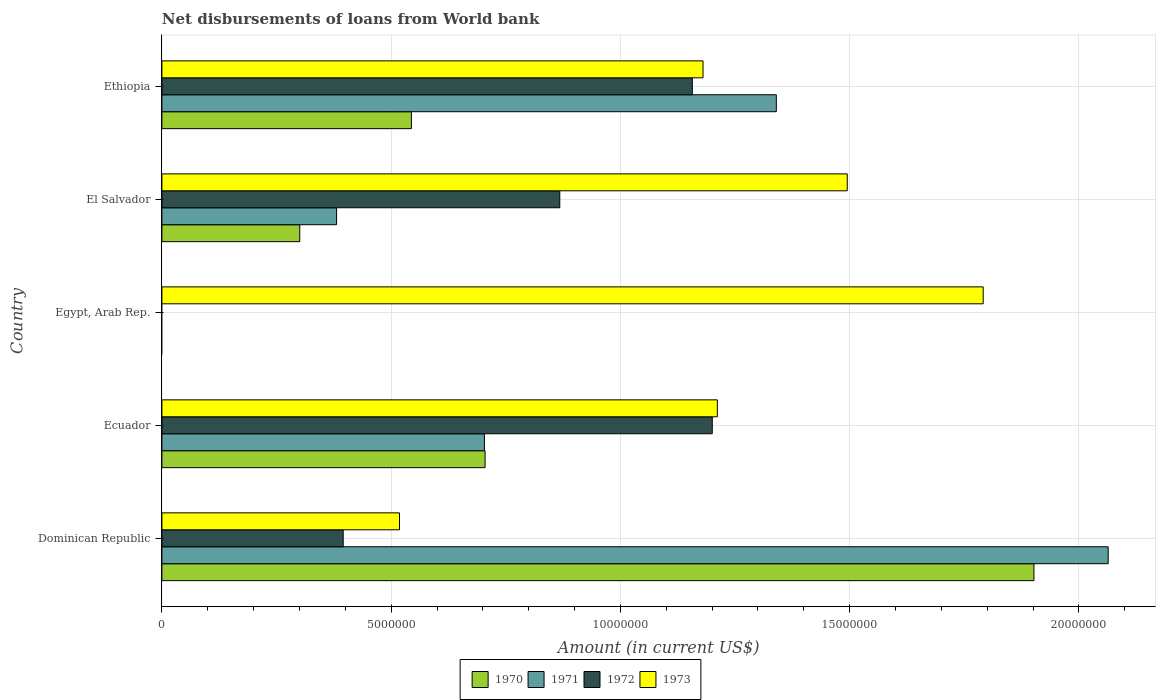How many different coloured bars are there?
Your answer should be compact. 4. How many bars are there on the 4th tick from the bottom?
Make the answer very short. 4. What is the label of the 5th group of bars from the top?
Offer a very short reply. Dominican Republic. In how many cases, is the number of bars for a given country not equal to the number of legend labels?
Give a very brief answer. 1. What is the amount of loan disbursed from World Bank in 1973 in Ethiopia?
Offer a very short reply. 1.18e+07. Across all countries, what is the maximum amount of loan disbursed from World Bank in 1972?
Offer a very short reply. 1.20e+07. In which country was the amount of loan disbursed from World Bank in 1972 maximum?
Keep it short and to the point. Ecuador. What is the total amount of loan disbursed from World Bank in 1973 in the graph?
Make the answer very short. 6.20e+07. What is the difference between the amount of loan disbursed from World Bank in 1973 in Dominican Republic and that in Ethiopia?
Your answer should be compact. -6.62e+06. What is the difference between the amount of loan disbursed from World Bank in 1971 in Egypt, Arab Rep. and the amount of loan disbursed from World Bank in 1973 in Ethiopia?
Your response must be concise. -1.18e+07. What is the average amount of loan disbursed from World Bank in 1970 per country?
Your answer should be compact. 6.90e+06. What is the difference between the amount of loan disbursed from World Bank in 1972 and amount of loan disbursed from World Bank in 1973 in Dominican Republic?
Your answer should be compact. -1.23e+06. In how many countries, is the amount of loan disbursed from World Bank in 1973 greater than 20000000 US$?
Give a very brief answer. 0. What is the ratio of the amount of loan disbursed from World Bank in 1973 in Dominican Republic to that in El Salvador?
Make the answer very short. 0.35. What is the difference between the highest and the second highest amount of loan disbursed from World Bank in 1971?
Offer a terse response. 7.24e+06. What is the difference between the highest and the lowest amount of loan disbursed from World Bank in 1971?
Your answer should be compact. 2.06e+07. In how many countries, is the amount of loan disbursed from World Bank in 1970 greater than the average amount of loan disbursed from World Bank in 1970 taken over all countries?
Your response must be concise. 2. Is the sum of the amount of loan disbursed from World Bank in 1973 in El Salvador and Ethiopia greater than the maximum amount of loan disbursed from World Bank in 1970 across all countries?
Your response must be concise. Yes. Is it the case that in every country, the sum of the amount of loan disbursed from World Bank in 1970 and amount of loan disbursed from World Bank in 1971 is greater than the amount of loan disbursed from World Bank in 1972?
Your response must be concise. No. Are all the bars in the graph horizontal?
Your response must be concise. Yes. How many countries are there in the graph?
Your answer should be compact. 5. What is the difference between two consecutive major ticks on the X-axis?
Ensure brevity in your answer.  5.00e+06. Are the values on the major ticks of X-axis written in scientific E-notation?
Keep it short and to the point. No. What is the title of the graph?
Make the answer very short. Net disbursements of loans from World bank. Does "1972" appear as one of the legend labels in the graph?
Keep it short and to the point. Yes. What is the label or title of the X-axis?
Ensure brevity in your answer.  Amount (in current US$). What is the label or title of the Y-axis?
Offer a very short reply. Country. What is the Amount (in current US$) in 1970 in Dominican Republic?
Ensure brevity in your answer.  1.90e+07. What is the Amount (in current US$) of 1971 in Dominican Republic?
Give a very brief answer. 2.06e+07. What is the Amount (in current US$) of 1972 in Dominican Republic?
Ensure brevity in your answer.  3.95e+06. What is the Amount (in current US$) in 1973 in Dominican Republic?
Provide a short and direct response. 5.18e+06. What is the Amount (in current US$) in 1970 in Ecuador?
Your answer should be compact. 7.05e+06. What is the Amount (in current US$) in 1971 in Ecuador?
Offer a very short reply. 7.03e+06. What is the Amount (in current US$) of 1972 in Ecuador?
Your response must be concise. 1.20e+07. What is the Amount (in current US$) in 1973 in Ecuador?
Offer a terse response. 1.21e+07. What is the Amount (in current US$) in 1970 in Egypt, Arab Rep.?
Your answer should be compact. 0. What is the Amount (in current US$) in 1973 in Egypt, Arab Rep.?
Your answer should be very brief. 1.79e+07. What is the Amount (in current US$) in 1970 in El Salvador?
Your answer should be very brief. 3.01e+06. What is the Amount (in current US$) in 1971 in El Salvador?
Your answer should be compact. 3.81e+06. What is the Amount (in current US$) in 1972 in El Salvador?
Offer a terse response. 8.68e+06. What is the Amount (in current US$) in 1973 in El Salvador?
Make the answer very short. 1.49e+07. What is the Amount (in current US$) of 1970 in Ethiopia?
Offer a very short reply. 5.44e+06. What is the Amount (in current US$) of 1971 in Ethiopia?
Make the answer very short. 1.34e+07. What is the Amount (in current US$) of 1972 in Ethiopia?
Provide a succinct answer. 1.16e+07. What is the Amount (in current US$) of 1973 in Ethiopia?
Keep it short and to the point. 1.18e+07. Across all countries, what is the maximum Amount (in current US$) of 1970?
Offer a very short reply. 1.90e+07. Across all countries, what is the maximum Amount (in current US$) in 1971?
Offer a very short reply. 2.06e+07. Across all countries, what is the maximum Amount (in current US$) of 1972?
Offer a terse response. 1.20e+07. Across all countries, what is the maximum Amount (in current US$) of 1973?
Give a very brief answer. 1.79e+07. Across all countries, what is the minimum Amount (in current US$) of 1970?
Offer a terse response. 0. Across all countries, what is the minimum Amount (in current US$) of 1972?
Offer a terse response. 0. Across all countries, what is the minimum Amount (in current US$) of 1973?
Your response must be concise. 5.18e+06. What is the total Amount (in current US$) of 1970 in the graph?
Your response must be concise. 3.45e+07. What is the total Amount (in current US$) in 1971 in the graph?
Your answer should be very brief. 4.49e+07. What is the total Amount (in current US$) in 1972 in the graph?
Offer a very short reply. 3.62e+07. What is the total Amount (in current US$) in 1973 in the graph?
Make the answer very short. 6.20e+07. What is the difference between the Amount (in current US$) in 1970 in Dominican Republic and that in Ecuador?
Provide a short and direct response. 1.20e+07. What is the difference between the Amount (in current US$) of 1971 in Dominican Republic and that in Ecuador?
Your answer should be very brief. 1.36e+07. What is the difference between the Amount (in current US$) of 1972 in Dominican Republic and that in Ecuador?
Offer a very short reply. -8.05e+06. What is the difference between the Amount (in current US$) of 1973 in Dominican Republic and that in Ecuador?
Offer a very short reply. -6.93e+06. What is the difference between the Amount (in current US$) of 1973 in Dominican Republic and that in Egypt, Arab Rep.?
Provide a short and direct response. -1.27e+07. What is the difference between the Amount (in current US$) in 1970 in Dominican Republic and that in El Salvador?
Your answer should be compact. 1.60e+07. What is the difference between the Amount (in current US$) in 1971 in Dominican Republic and that in El Salvador?
Keep it short and to the point. 1.68e+07. What is the difference between the Amount (in current US$) in 1972 in Dominican Republic and that in El Salvador?
Offer a terse response. -4.72e+06. What is the difference between the Amount (in current US$) of 1973 in Dominican Republic and that in El Salvador?
Ensure brevity in your answer.  -9.77e+06. What is the difference between the Amount (in current US$) in 1970 in Dominican Republic and that in Ethiopia?
Offer a very short reply. 1.36e+07. What is the difference between the Amount (in current US$) in 1971 in Dominican Republic and that in Ethiopia?
Provide a short and direct response. 7.24e+06. What is the difference between the Amount (in current US$) of 1972 in Dominican Republic and that in Ethiopia?
Give a very brief answer. -7.62e+06. What is the difference between the Amount (in current US$) in 1973 in Dominican Republic and that in Ethiopia?
Ensure brevity in your answer.  -6.62e+06. What is the difference between the Amount (in current US$) of 1973 in Ecuador and that in Egypt, Arab Rep.?
Give a very brief answer. -5.80e+06. What is the difference between the Amount (in current US$) in 1970 in Ecuador and that in El Salvador?
Your response must be concise. 4.04e+06. What is the difference between the Amount (in current US$) in 1971 in Ecuador and that in El Salvador?
Your answer should be compact. 3.22e+06. What is the difference between the Amount (in current US$) of 1972 in Ecuador and that in El Salvador?
Provide a short and direct response. 3.33e+06. What is the difference between the Amount (in current US$) of 1973 in Ecuador and that in El Salvador?
Your answer should be compact. -2.83e+06. What is the difference between the Amount (in current US$) in 1970 in Ecuador and that in Ethiopia?
Provide a short and direct response. 1.61e+06. What is the difference between the Amount (in current US$) of 1971 in Ecuador and that in Ethiopia?
Your answer should be very brief. -6.37e+06. What is the difference between the Amount (in current US$) in 1972 in Ecuador and that in Ethiopia?
Give a very brief answer. 4.35e+05. What is the difference between the Amount (in current US$) of 1973 in Ecuador and that in Ethiopia?
Keep it short and to the point. 3.13e+05. What is the difference between the Amount (in current US$) in 1973 in Egypt, Arab Rep. and that in El Salvador?
Provide a short and direct response. 2.96e+06. What is the difference between the Amount (in current US$) of 1973 in Egypt, Arab Rep. and that in Ethiopia?
Your answer should be very brief. 6.11e+06. What is the difference between the Amount (in current US$) in 1970 in El Salvador and that in Ethiopia?
Keep it short and to the point. -2.44e+06. What is the difference between the Amount (in current US$) in 1971 in El Salvador and that in Ethiopia?
Ensure brevity in your answer.  -9.59e+06. What is the difference between the Amount (in current US$) in 1972 in El Salvador and that in Ethiopia?
Provide a short and direct response. -2.89e+06. What is the difference between the Amount (in current US$) of 1973 in El Salvador and that in Ethiopia?
Give a very brief answer. 3.15e+06. What is the difference between the Amount (in current US$) in 1970 in Dominican Republic and the Amount (in current US$) in 1971 in Ecuador?
Provide a short and direct response. 1.20e+07. What is the difference between the Amount (in current US$) of 1970 in Dominican Republic and the Amount (in current US$) of 1972 in Ecuador?
Provide a short and direct response. 7.02e+06. What is the difference between the Amount (in current US$) of 1970 in Dominican Republic and the Amount (in current US$) of 1973 in Ecuador?
Your response must be concise. 6.90e+06. What is the difference between the Amount (in current US$) in 1971 in Dominican Republic and the Amount (in current US$) in 1972 in Ecuador?
Offer a very short reply. 8.64e+06. What is the difference between the Amount (in current US$) in 1971 in Dominican Republic and the Amount (in current US$) in 1973 in Ecuador?
Offer a very short reply. 8.52e+06. What is the difference between the Amount (in current US$) in 1972 in Dominican Republic and the Amount (in current US$) in 1973 in Ecuador?
Ensure brevity in your answer.  -8.16e+06. What is the difference between the Amount (in current US$) in 1970 in Dominican Republic and the Amount (in current US$) in 1973 in Egypt, Arab Rep.?
Keep it short and to the point. 1.11e+06. What is the difference between the Amount (in current US$) of 1971 in Dominican Republic and the Amount (in current US$) of 1973 in Egypt, Arab Rep.?
Your response must be concise. 2.73e+06. What is the difference between the Amount (in current US$) in 1972 in Dominican Republic and the Amount (in current US$) in 1973 in Egypt, Arab Rep.?
Ensure brevity in your answer.  -1.40e+07. What is the difference between the Amount (in current US$) in 1970 in Dominican Republic and the Amount (in current US$) in 1971 in El Salvador?
Offer a very short reply. 1.52e+07. What is the difference between the Amount (in current US$) in 1970 in Dominican Republic and the Amount (in current US$) in 1972 in El Salvador?
Your answer should be very brief. 1.03e+07. What is the difference between the Amount (in current US$) in 1970 in Dominican Republic and the Amount (in current US$) in 1973 in El Salvador?
Ensure brevity in your answer.  4.07e+06. What is the difference between the Amount (in current US$) of 1971 in Dominican Republic and the Amount (in current US$) of 1972 in El Salvador?
Give a very brief answer. 1.20e+07. What is the difference between the Amount (in current US$) of 1971 in Dominican Republic and the Amount (in current US$) of 1973 in El Salvador?
Give a very brief answer. 5.69e+06. What is the difference between the Amount (in current US$) in 1972 in Dominican Republic and the Amount (in current US$) in 1973 in El Salvador?
Provide a succinct answer. -1.10e+07. What is the difference between the Amount (in current US$) in 1970 in Dominican Republic and the Amount (in current US$) in 1971 in Ethiopia?
Keep it short and to the point. 5.62e+06. What is the difference between the Amount (in current US$) of 1970 in Dominican Republic and the Amount (in current US$) of 1972 in Ethiopia?
Your response must be concise. 7.45e+06. What is the difference between the Amount (in current US$) in 1970 in Dominican Republic and the Amount (in current US$) in 1973 in Ethiopia?
Offer a very short reply. 7.22e+06. What is the difference between the Amount (in current US$) in 1971 in Dominican Republic and the Amount (in current US$) in 1972 in Ethiopia?
Give a very brief answer. 9.07e+06. What is the difference between the Amount (in current US$) of 1971 in Dominican Republic and the Amount (in current US$) of 1973 in Ethiopia?
Give a very brief answer. 8.84e+06. What is the difference between the Amount (in current US$) of 1972 in Dominican Republic and the Amount (in current US$) of 1973 in Ethiopia?
Your answer should be compact. -7.85e+06. What is the difference between the Amount (in current US$) of 1970 in Ecuador and the Amount (in current US$) of 1973 in Egypt, Arab Rep.?
Offer a terse response. -1.09e+07. What is the difference between the Amount (in current US$) in 1971 in Ecuador and the Amount (in current US$) in 1973 in Egypt, Arab Rep.?
Give a very brief answer. -1.09e+07. What is the difference between the Amount (in current US$) of 1972 in Ecuador and the Amount (in current US$) of 1973 in Egypt, Arab Rep.?
Your answer should be very brief. -5.91e+06. What is the difference between the Amount (in current US$) in 1970 in Ecuador and the Amount (in current US$) in 1971 in El Salvador?
Offer a terse response. 3.24e+06. What is the difference between the Amount (in current US$) in 1970 in Ecuador and the Amount (in current US$) in 1972 in El Salvador?
Offer a terse response. -1.63e+06. What is the difference between the Amount (in current US$) of 1970 in Ecuador and the Amount (in current US$) of 1973 in El Salvador?
Offer a very short reply. -7.90e+06. What is the difference between the Amount (in current US$) in 1971 in Ecuador and the Amount (in current US$) in 1972 in El Salvador?
Provide a succinct answer. -1.64e+06. What is the difference between the Amount (in current US$) in 1971 in Ecuador and the Amount (in current US$) in 1973 in El Salvador?
Your answer should be compact. -7.91e+06. What is the difference between the Amount (in current US$) in 1972 in Ecuador and the Amount (in current US$) in 1973 in El Salvador?
Your answer should be very brief. -2.94e+06. What is the difference between the Amount (in current US$) in 1970 in Ecuador and the Amount (in current US$) in 1971 in Ethiopia?
Give a very brief answer. -6.35e+06. What is the difference between the Amount (in current US$) of 1970 in Ecuador and the Amount (in current US$) of 1972 in Ethiopia?
Keep it short and to the point. -4.52e+06. What is the difference between the Amount (in current US$) of 1970 in Ecuador and the Amount (in current US$) of 1973 in Ethiopia?
Provide a short and direct response. -4.75e+06. What is the difference between the Amount (in current US$) in 1971 in Ecuador and the Amount (in current US$) in 1972 in Ethiopia?
Offer a very short reply. -4.54e+06. What is the difference between the Amount (in current US$) in 1971 in Ecuador and the Amount (in current US$) in 1973 in Ethiopia?
Offer a very short reply. -4.77e+06. What is the difference between the Amount (in current US$) of 1972 in Ecuador and the Amount (in current US$) of 1973 in Ethiopia?
Offer a very short reply. 2.02e+05. What is the difference between the Amount (in current US$) in 1970 in El Salvador and the Amount (in current US$) in 1971 in Ethiopia?
Provide a succinct answer. -1.04e+07. What is the difference between the Amount (in current US$) of 1970 in El Salvador and the Amount (in current US$) of 1972 in Ethiopia?
Your response must be concise. -8.56e+06. What is the difference between the Amount (in current US$) of 1970 in El Salvador and the Amount (in current US$) of 1973 in Ethiopia?
Your answer should be very brief. -8.80e+06. What is the difference between the Amount (in current US$) in 1971 in El Salvador and the Amount (in current US$) in 1972 in Ethiopia?
Make the answer very short. -7.76e+06. What is the difference between the Amount (in current US$) in 1971 in El Salvador and the Amount (in current US$) in 1973 in Ethiopia?
Provide a short and direct response. -7.99e+06. What is the difference between the Amount (in current US$) in 1972 in El Salvador and the Amount (in current US$) in 1973 in Ethiopia?
Offer a terse response. -3.12e+06. What is the average Amount (in current US$) in 1970 per country?
Provide a short and direct response. 6.90e+06. What is the average Amount (in current US$) in 1971 per country?
Offer a very short reply. 8.98e+06. What is the average Amount (in current US$) of 1972 per country?
Your answer should be very brief. 7.24e+06. What is the average Amount (in current US$) of 1973 per country?
Offer a very short reply. 1.24e+07. What is the difference between the Amount (in current US$) in 1970 and Amount (in current US$) in 1971 in Dominican Republic?
Keep it short and to the point. -1.62e+06. What is the difference between the Amount (in current US$) in 1970 and Amount (in current US$) in 1972 in Dominican Republic?
Offer a very short reply. 1.51e+07. What is the difference between the Amount (in current US$) of 1970 and Amount (in current US$) of 1973 in Dominican Republic?
Your answer should be compact. 1.38e+07. What is the difference between the Amount (in current US$) of 1971 and Amount (in current US$) of 1972 in Dominican Republic?
Provide a short and direct response. 1.67e+07. What is the difference between the Amount (in current US$) in 1971 and Amount (in current US$) in 1973 in Dominican Republic?
Provide a short and direct response. 1.55e+07. What is the difference between the Amount (in current US$) in 1972 and Amount (in current US$) in 1973 in Dominican Republic?
Give a very brief answer. -1.23e+06. What is the difference between the Amount (in current US$) in 1970 and Amount (in current US$) in 1971 in Ecuador?
Your answer should be compact. 1.50e+04. What is the difference between the Amount (in current US$) in 1970 and Amount (in current US$) in 1972 in Ecuador?
Provide a succinct answer. -4.96e+06. What is the difference between the Amount (in current US$) in 1970 and Amount (in current US$) in 1973 in Ecuador?
Provide a short and direct response. -5.07e+06. What is the difference between the Amount (in current US$) of 1971 and Amount (in current US$) of 1972 in Ecuador?
Keep it short and to the point. -4.97e+06. What is the difference between the Amount (in current US$) of 1971 and Amount (in current US$) of 1973 in Ecuador?
Provide a succinct answer. -5.08e+06. What is the difference between the Amount (in current US$) in 1972 and Amount (in current US$) in 1973 in Ecuador?
Ensure brevity in your answer.  -1.11e+05. What is the difference between the Amount (in current US$) of 1970 and Amount (in current US$) of 1971 in El Salvador?
Give a very brief answer. -8.03e+05. What is the difference between the Amount (in current US$) in 1970 and Amount (in current US$) in 1972 in El Salvador?
Make the answer very short. -5.67e+06. What is the difference between the Amount (in current US$) in 1970 and Amount (in current US$) in 1973 in El Salvador?
Give a very brief answer. -1.19e+07. What is the difference between the Amount (in current US$) of 1971 and Amount (in current US$) of 1972 in El Salvador?
Give a very brief answer. -4.87e+06. What is the difference between the Amount (in current US$) of 1971 and Amount (in current US$) of 1973 in El Salvador?
Make the answer very short. -1.11e+07. What is the difference between the Amount (in current US$) in 1972 and Amount (in current US$) in 1973 in El Salvador?
Offer a very short reply. -6.27e+06. What is the difference between the Amount (in current US$) in 1970 and Amount (in current US$) in 1971 in Ethiopia?
Provide a succinct answer. -7.96e+06. What is the difference between the Amount (in current US$) in 1970 and Amount (in current US$) in 1972 in Ethiopia?
Your answer should be compact. -6.13e+06. What is the difference between the Amount (in current US$) in 1970 and Amount (in current US$) in 1973 in Ethiopia?
Offer a very short reply. -6.36e+06. What is the difference between the Amount (in current US$) of 1971 and Amount (in current US$) of 1972 in Ethiopia?
Provide a short and direct response. 1.83e+06. What is the difference between the Amount (in current US$) of 1971 and Amount (in current US$) of 1973 in Ethiopia?
Your response must be concise. 1.60e+06. What is the difference between the Amount (in current US$) in 1972 and Amount (in current US$) in 1973 in Ethiopia?
Provide a short and direct response. -2.33e+05. What is the ratio of the Amount (in current US$) in 1970 in Dominican Republic to that in Ecuador?
Ensure brevity in your answer.  2.7. What is the ratio of the Amount (in current US$) of 1971 in Dominican Republic to that in Ecuador?
Provide a short and direct response. 2.93. What is the ratio of the Amount (in current US$) of 1972 in Dominican Republic to that in Ecuador?
Ensure brevity in your answer.  0.33. What is the ratio of the Amount (in current US$) of 1973 in Dominican Republic to that in Ecuador?
Provide a short and direct response. 0.43. What is the ratio of the Amount (in current US$) in 1973 in Dominican Republic to that in Egypt, Arab Rep.?
Keep it short and to the point. 0.29. What is the ratio of the Amount (in current US$) in 1970 in Dominican Republic to that in El Salvador?
Offer a very short reply. 6.33. What is the ratio of the Amount (in current US$) of 1971 in Dominican Republic to that in El Salvador?
Keep it short and to the point. 5.42. What is the ratio of the Amount (in current US$) in 1972 in Dominican Republic to that in El Salvador?
Your response must be concise. 0.46. What is the ratio of the Amount (in current US$) of 1973 in Dominican Republic to that in El Salvador?
Ensure brevity in your answer.  0.35. What is the ratio of the Amount (in current US$) of 1970 in Dominican Republic to that in Ethiopia?
Your answer should be very brief. 3.5. What is the ratio of the Amount (in current US$) in 1971 in Dominican Republic to that in Ethiopia?
Provide a short and direct response. 1.54. What is the ratio of the Amount (in current US$) of 1972 in Dominican Republic to that in Ethiopia?
Keep it short and to the point. 0.34. What is the ratio of the Amount (in current US$) in 1973 in Dominican Republic to that in Ethiopia?
Keep it short and to the point. 0.44. What is the ratio of the Amount (in current US$) of 1973 in Ecuador to that in Egypt, Arab Rep.?
Ensure brevity in your answer.  0.68. What is the ratio of the Amount (in current US$) of 1970 in Ecuador to that in El Salvador?
Keep it short and to the point. 2.34. What is the ratio of the Amount (in current US$) in 1971 in Ecuador to that in El Salvador?
Ensure brevity in your answer.  1.85. What is the ratio of the Amount (in current US$) of 1972 in Ecuador to that in El Salvador?
Your answer should be compact. 1.38. What is the ratio of the Amount (in current US$) of 1973 in Ecuador to that in El Salvador?
Provide a short and direct response. 0.81. What is the ratio of the Amount (in current US$) of 1970 in Ecuador to that in Ethiopia?
Give a very brief answer. 1.3. What is the ratio of the Amount (in current US$) in 1971 in Ecuador to that in Ethiopia?
Provide a succinct answer. 0.52. What is the ratio of the Amount (in current US$) in 1972 in Ecuador to that in Ethiopia?
Provide a succinct answer. 1.04. What is the ratio of the Amount (in current US$) of 1973 in Ecuador to that in Ethiopia?
Provide a succinct answer. 1.03. What is the ratio of the Amount (in current US$) of 1973 in Egypt, Arab Rep. to that in El Salvador?
Make the answer very short. 1.2. What is the ratio of the Amount (in current US$) of 1973 in Egypt, Arab Rep. to that in Ethiopia?
Your answer should be compact. 1.52. What is the ratio of the Amount (in current US$) of 1970 in El Salvador to that in Ethiopia?
Give a very brief answer. 0.55. What is the ratio of the Amount (in current US$) of 1971 in El Salvador to that in Ethiopia?
Your answer should be compact. 0.28. What is the ratio of the Amount (in current US$) in 1972 in El Salvador to that in Ethiopia?
Offer a very short reply. 0.75. What is the ratio of the Amount (in current US$) of 1973 in El Salvador to that in Ethiopia?
Your response must be concise. 1.27. What is the difference between the highest and the second highest Amount (in current US$) in 1970?
Your answer should be compact. 1.20e+07. What is the difference between the highest and the second highest Amount (in current US$) in 1971?
Provide a succinct answer. 7.24e+06. What is the difference between the highest and the second highest Amount (in current US$) of 1972?
Provide a short and direct response. 4.35e+05. What is the difference between the highest and the second highest Amount (in current US$) of 1973?
Give a very brief answer. 2.96e+06. What is the difference between the highest and the lowest Amount (in current US$) of 1970?
Your response must be concise. 1.90e+07. What is the difference between the highest and the lowest Amount (in current US$) in 1971?
Keep it short and to the point. 2.06e+07. What is the difference between the highest and the lowest Amount (in current US$) in 1972?
Provide a succinct answer. 1.20e+07. What is the difference between the highest and the lowest Amount (in current US$) of 1973?
Your answer should be compact. 1.27e+07. 